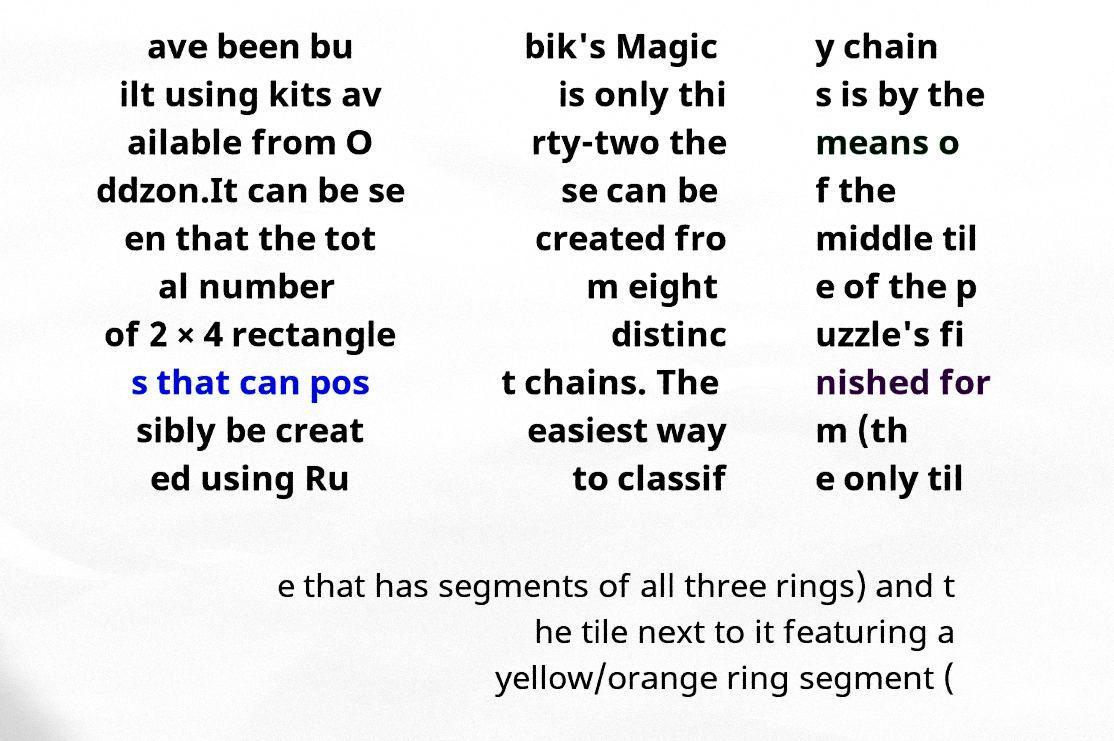Please identify and transcribe the text found in this image. ave been bu ilt using kits av ailable from O ddzon.It can be se en that the tot al number of 2 × 4 rectangle s that can pos sibly be creat ed using Ru bik's Magic is only thi rty-two the se can be created fro m eight distinc t chains. The easiest way to classif y chain s is by the means o f the middle til e of the p uzzle's fi nished for m (th e only til e that has segments of all three rings) and t he tile next to it featuring a yellow/orange ring segment ( 